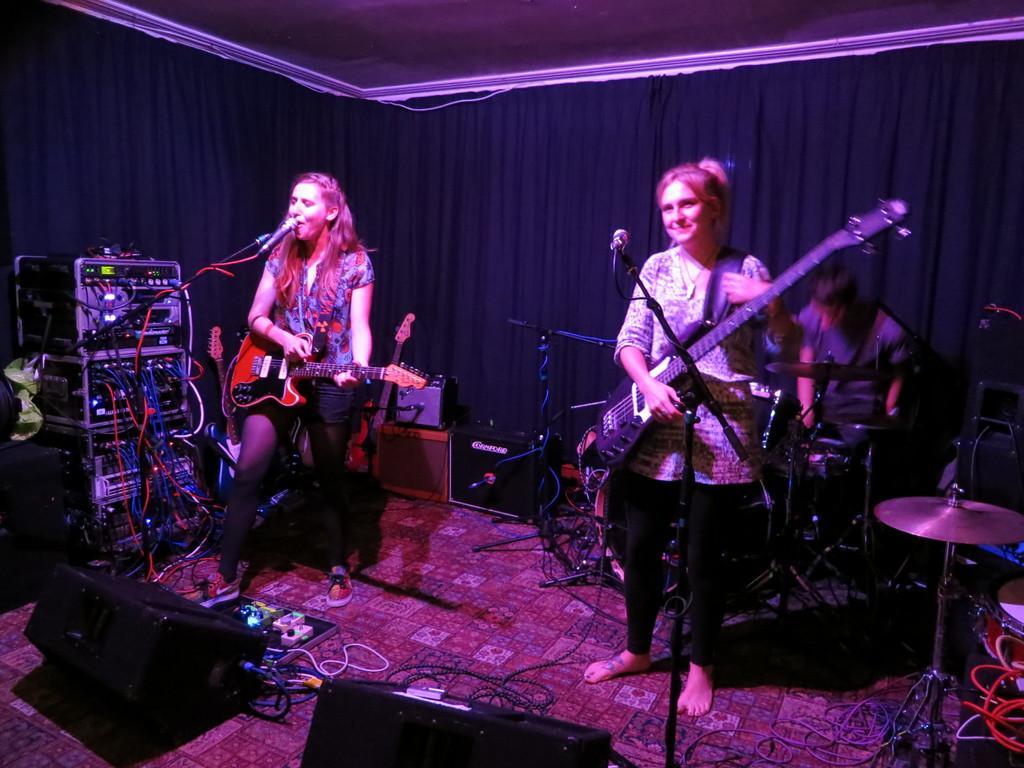Describe this image in one or two sentences. As we can see in the image there are three people. Among them two of them are standing and holding guitar in their hands. 